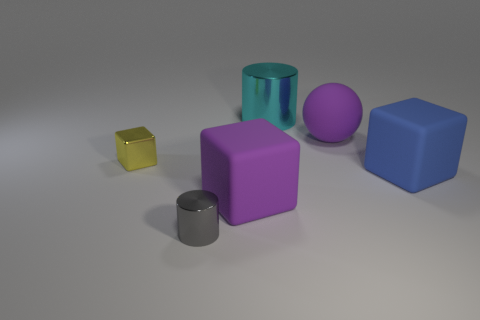There is a large cube that is the same color as the rubber sphere; what material is it?
Your answer should be compact. Rubber. What number of small objects have the same shape as the big blue object?
Your answer should be very brief. 1. Do the blue thing and the big block on the left side of the cyan thing have the same material?
Your answer should be compact. Yes. There is a cylinder that is the same size as the blue cube; what is it made of?
Give a very brief answer. Metal. Is there a yellow metal block of the same size as the gray cylinder?
Provide a short and direct response. Yes. There is a cyan thing that is the same size as the blue object; what shape is it?
Give a very brief answer. Cylinder. How many other objects are the same color as the sphere?
Ensure brevity in your answer.  1. What is the shape of the shiny object that is both to the right of the yellow thing and to the left of the big cyan metal cylinder?
Offer a terse response. Cylinder. Is there a metal thing that is in front of the cylinder that is in front of the thing that is on the left side of the gray shiny cylinder?
Your answer should be compact. No. How many other objects are there of the same material as the big purple block?
Your answer should be compact. 2. 